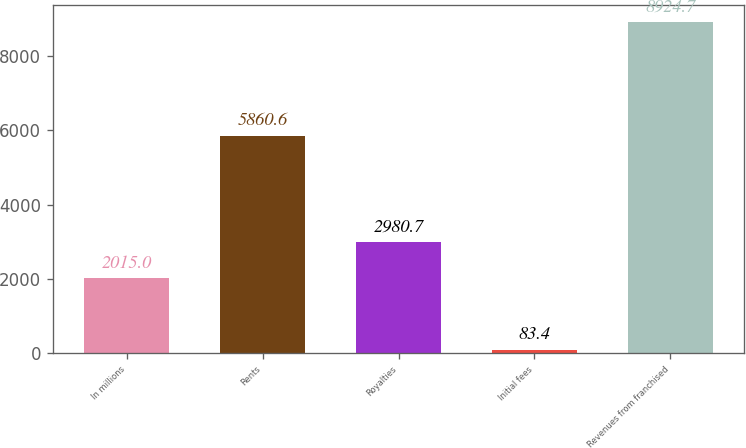Convert chart to OTSL. <chart><loc_0><loc_0><loc_500><loc_500><bar_chart><fcel>In millions<fcel>Rents<fcel>Royalties<fcel>Initial fees<fcel>Revenues from franchised<nl><fcel>2015<fcel>5860.6<fcel>2980.7<fcel>83.4<fcel>8924.7<nl></chart> 